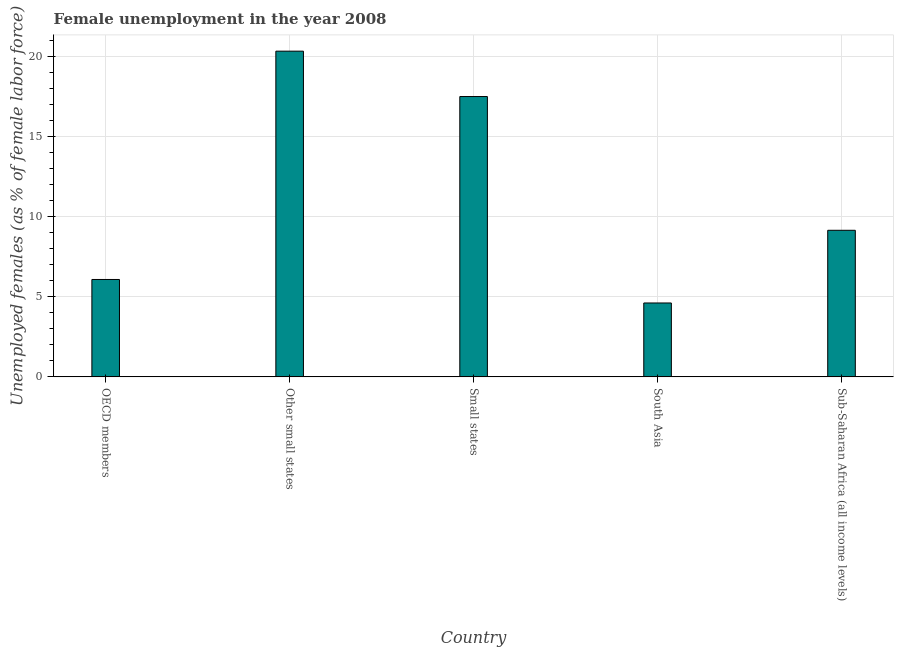Does the graph contain grids?
Give a very brief answer. Yes. What is the title of the graph?
Your answer should be very brief. Female unemployment in the year 2008. What is the label or title of the X-axis?
Your answer should be very brief. Country. What is the label or title of the Y-axis?
Offer a very short reply. Unemployed females (as % of female labor force). What is the unemployed females population in South Asia?
Provide a succinct answer. 4.62. Across all countries, what is the maximum unemployed females population?
Your answer should be very brief. 20.35. Across all countries, what is the minimum unemployed females population?
Your response must be concise. 4.62. In which country was the unemployed females population maximum?
Give a very brief answer. Other small states. What is the sum of the unemployed females population?
Provide a succinct answer. 57.72. What is the difference between the unemployed females population in OECD members and Other small states?
Keep it short and to the point. -14.26. What is the average unemployed females population per country?
Make the answer very short. 11.54. What is the median unemployed females population?
Offer a very short reply. 9.16. In how many countries, is the unemployed females population greater than 11 %?
Provide a short and direct response. 2. What is the ratio of the unemployed females population in Other small states to that in Sub-Saharan Africa (all income levels)?
Provide a short and direct response. 2.22. What is the difference between the highest and the second highest unemployed females population?
Your answer should be very brief. 2.83. What is the difference between the highest and the lowest unemployed females population?
Provide a succinct answer. 15.73. In how many countries, is the unemployed females population greater than the average unemployed females population taken over all countries?
Offer a terse response. 2. How many countries are there in the graph?
Keep it short and to the point. 5. What is the difference between two consecutive major ticks on the Y-axis?
Your response must be concise. 5. Are the values on the major ticks of Y-axis written in scientific E-notation?
Your answer should be compact. No. What is the Unemployed females (as % of female labor force) of OECD members?
Keep it short and to the point. 6.08. What is the Unemployed females (as % of female labor force) of Other small states?
Ensure brevity in your answer.  20.35. What is the Unemployed females (as % of female labor force) of Small states?
Offer a very short reply. 17.51. What is the Unemployed females (as % of female labor force) of South Asia?
Ensure brevity in your answer.  4.62. What is the Unemployed females (as % of female labor force) of Sub-Saharan Africa (all income levels)?
Give a very brief answer. 9.16. What is the difference between the Unemployed females (as % of female labor force) in OECD members and Other small states?
Offer a very short reply. -14.26. What is the difference between the Unemployed females (as % of female labor force) in OECD members and Small states?
Offer a very short reply. -11.43. What is the difference between the Unemployed females (as % of female labor force) in OECD members and South Asia?
Make the answer very short. 1.47. What is the difference between the Unemployed females (as % of female labor force) in OECD members and Sub-Saharan Africa (all income levels)?
Ensure brevity in your answer.  -3.07. What is the difference between the Unemployed females (as % of female labor force) in Other small states and Small states?
Ensure brevity in your answer.  2.83. What is the difference between the Unemployed females (as % of female labor force) in Other small states and South Asia?
Make the answer very short. 15.73. What is the difference between the Unemployed females (as % of female labor force) in Other small states and Sub-Saharan Africa (all income levels)?
Your answer should be very brief. 11.19. What is the difference between the Unemployed females (as % of female labor force) in Small states and South Asia?
Your answer should be compact. 12.9. What is the difference between the Unemployed females (as % of female labor force) in Small states and Sub-Saharan Africa (all income levels)?
Ensure brevity in your answer.  8.36. What is the difference between the Unemployed females (as % of female labor force) in South Asia and Sub-Saharan Africa (all income levels)?
Give a very brief answer. -4.54. What is the ratio of the Unemployed females (as % of female labor force) in OECD members to that in Other small states?
Your answer should be compact. 0.3. What is the ratio of the Unemployed females (as % of female labor force) in OECD members to that in Small states?
Keep it short and to the point. 0.35. What is the ratio of the Unemployed females (as % of female labor force) in OECD members to that in South Asia?
Offer a very short reply. 1.32. What is the ratio of the Unemployed females (as % of female labor force) in OECD members to that in Sub-Saharan Africa (all income levels)?
Your answer should be very brief. 0.66. What is the ratio of the Unemployed females (as % of female labor force) in Other small states to that in Small states?
Provide a succinct answer. 1.16. What is the ratio of the Unemployed females (as % of female labor force) in Other small states to that in South Asia?
Keep it short and to the point. 4.41. What is the ratio of the Unemployed females (as % of female labor force) in Other small states to that in Sub-Saharan Africa (all income levels)?
Provide a succinct answer. 2.22. What is the ratio of the Unemployed females (as % of female labor force) in Small states to that in South Asia?
Offer a very short reply. 3.79. What is the ratio of the Unemployed females (as % of female labor force) in Small states to that in Sub-Saharan Africa (all income levels)?
Keep it short and to the point. 1.91. What is the ratio of the Unemployed females (as % of female labor force) in South Asia to that in Sub-Saharan Africa (all income levels)?
Give a very brief answer. 0.5. 